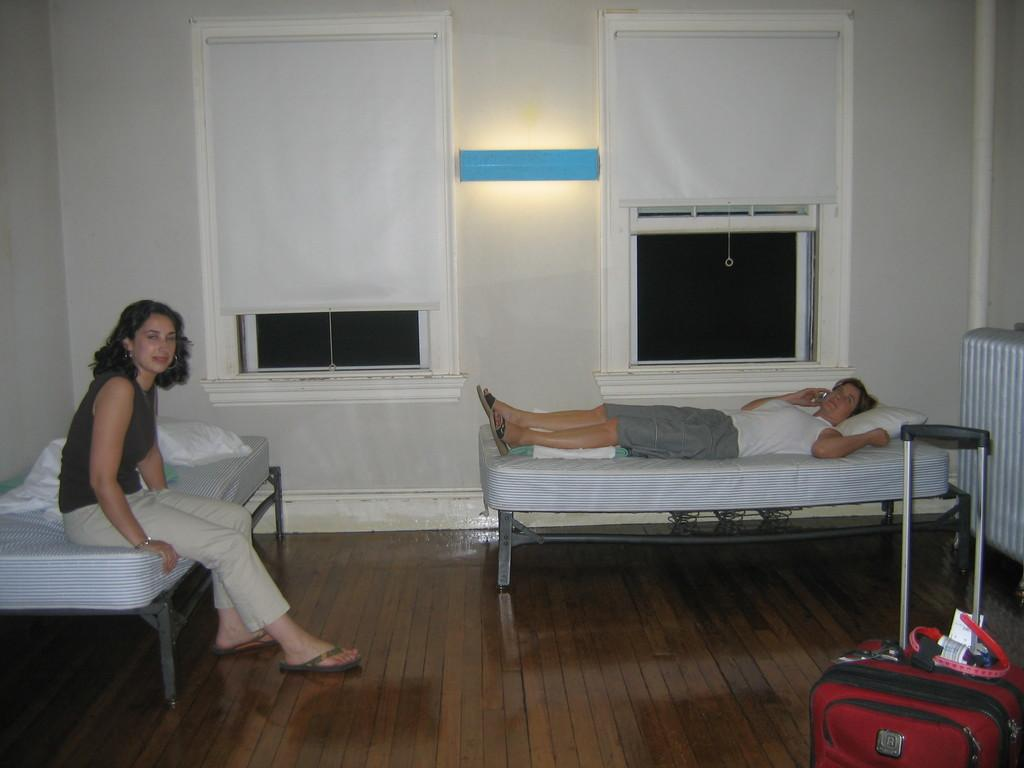What is the position of the person in the image? There is a person lying on the bed. Can you describe the other person in the image? There is a woman sitting on the bed. What type of wine is the person holding in the image? There is no wine present in the image; it only features a person lying on the bed and a woman sitting on the bed. 